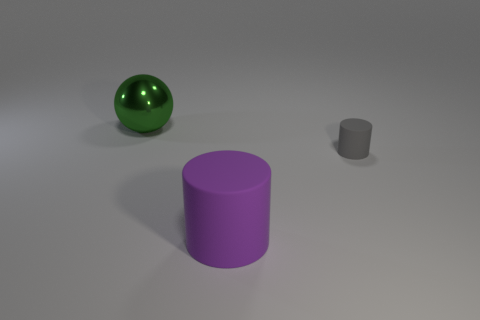Are there more big green spheres to the left of the green object than large things on the right side of the tiny rubber cylinder?
Provide a succinct answer. No. How many green objects have the same material as the tiny gray thing?
Give a very brief answer. 0. Is the size of the green metallic ball the same as the purple cylinder?
Provide a succinct answer. Yes. What is the color of the metal thing?
Ensure brevity in your answer.  Green. What number of things are tiny gray matte cylinders or large red matte things?
Give a very brief answer. 1. Is there another gray object that has the same shape as the big metal thing?
Provide a succinct answer. No. Does the large thing right of the sphere have the same color as the small thing?
Make the answer very short. No. There is a matte thing that is behind the cylinder that is to the left of the small gray thing; what is its shape?
Provide a short and direct response. Cylinder. Is there a green metal object that has the same size as the purple matte cylinder?
Provide a short and direct response. Yes. Is the number of gray matte objects less than the number of large brown matte balls?
Offer a very short reply. No. 